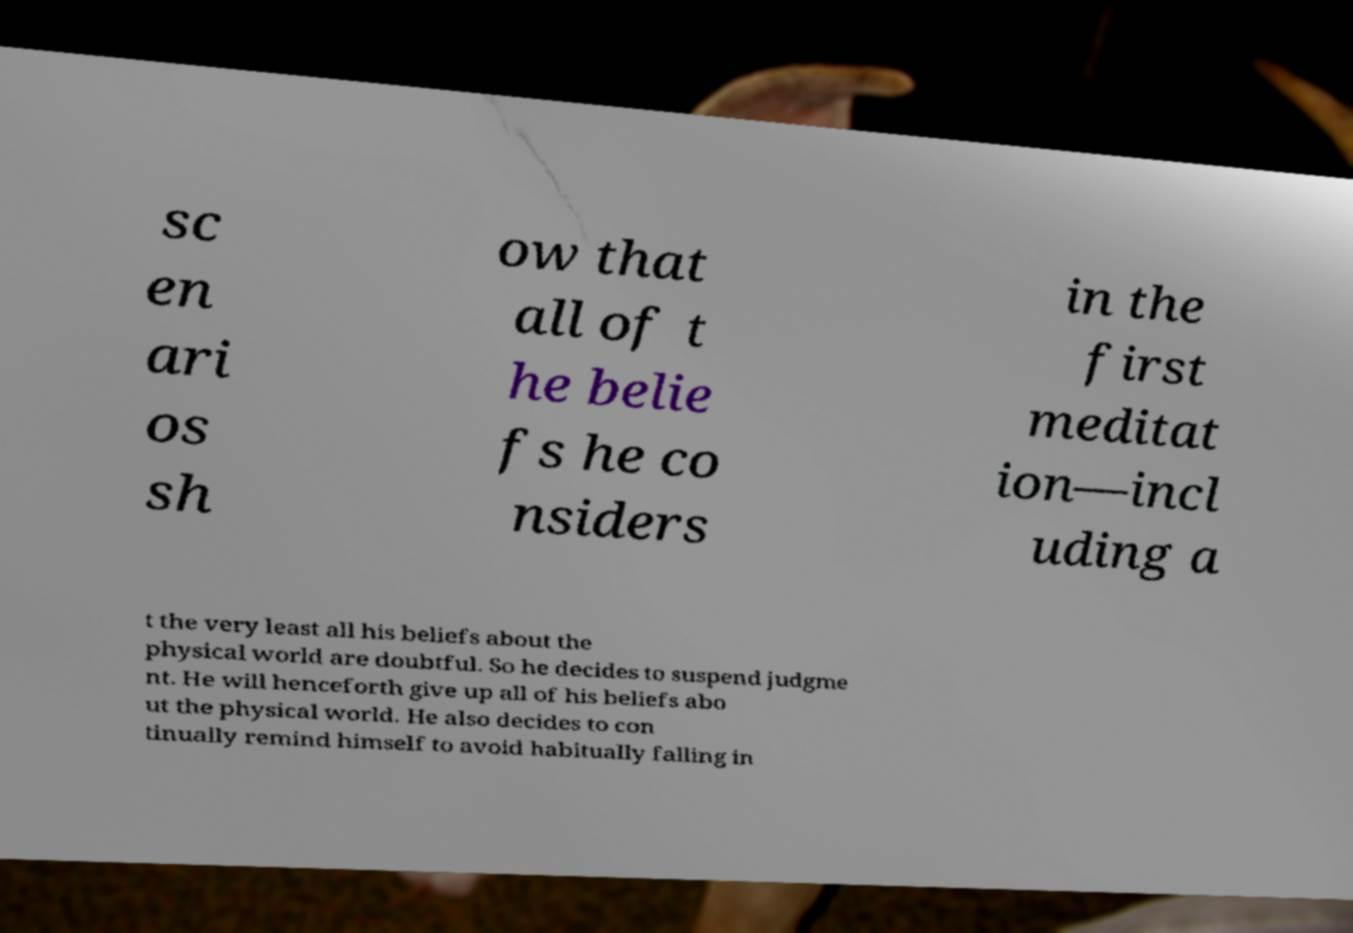Please identify and transcribe the text found in this image. sc en ari os sh ow that all of t he belie fs he co nsiders in the first meditat ion—incl uding a t the very least all his beliefs about the physical world are doubtful. So he decides to suspend judgme nt. He will henceforth give up all of his beliefs abo ut the physical world. He also decides to con tinually remind himself to avoid habitually falling in 